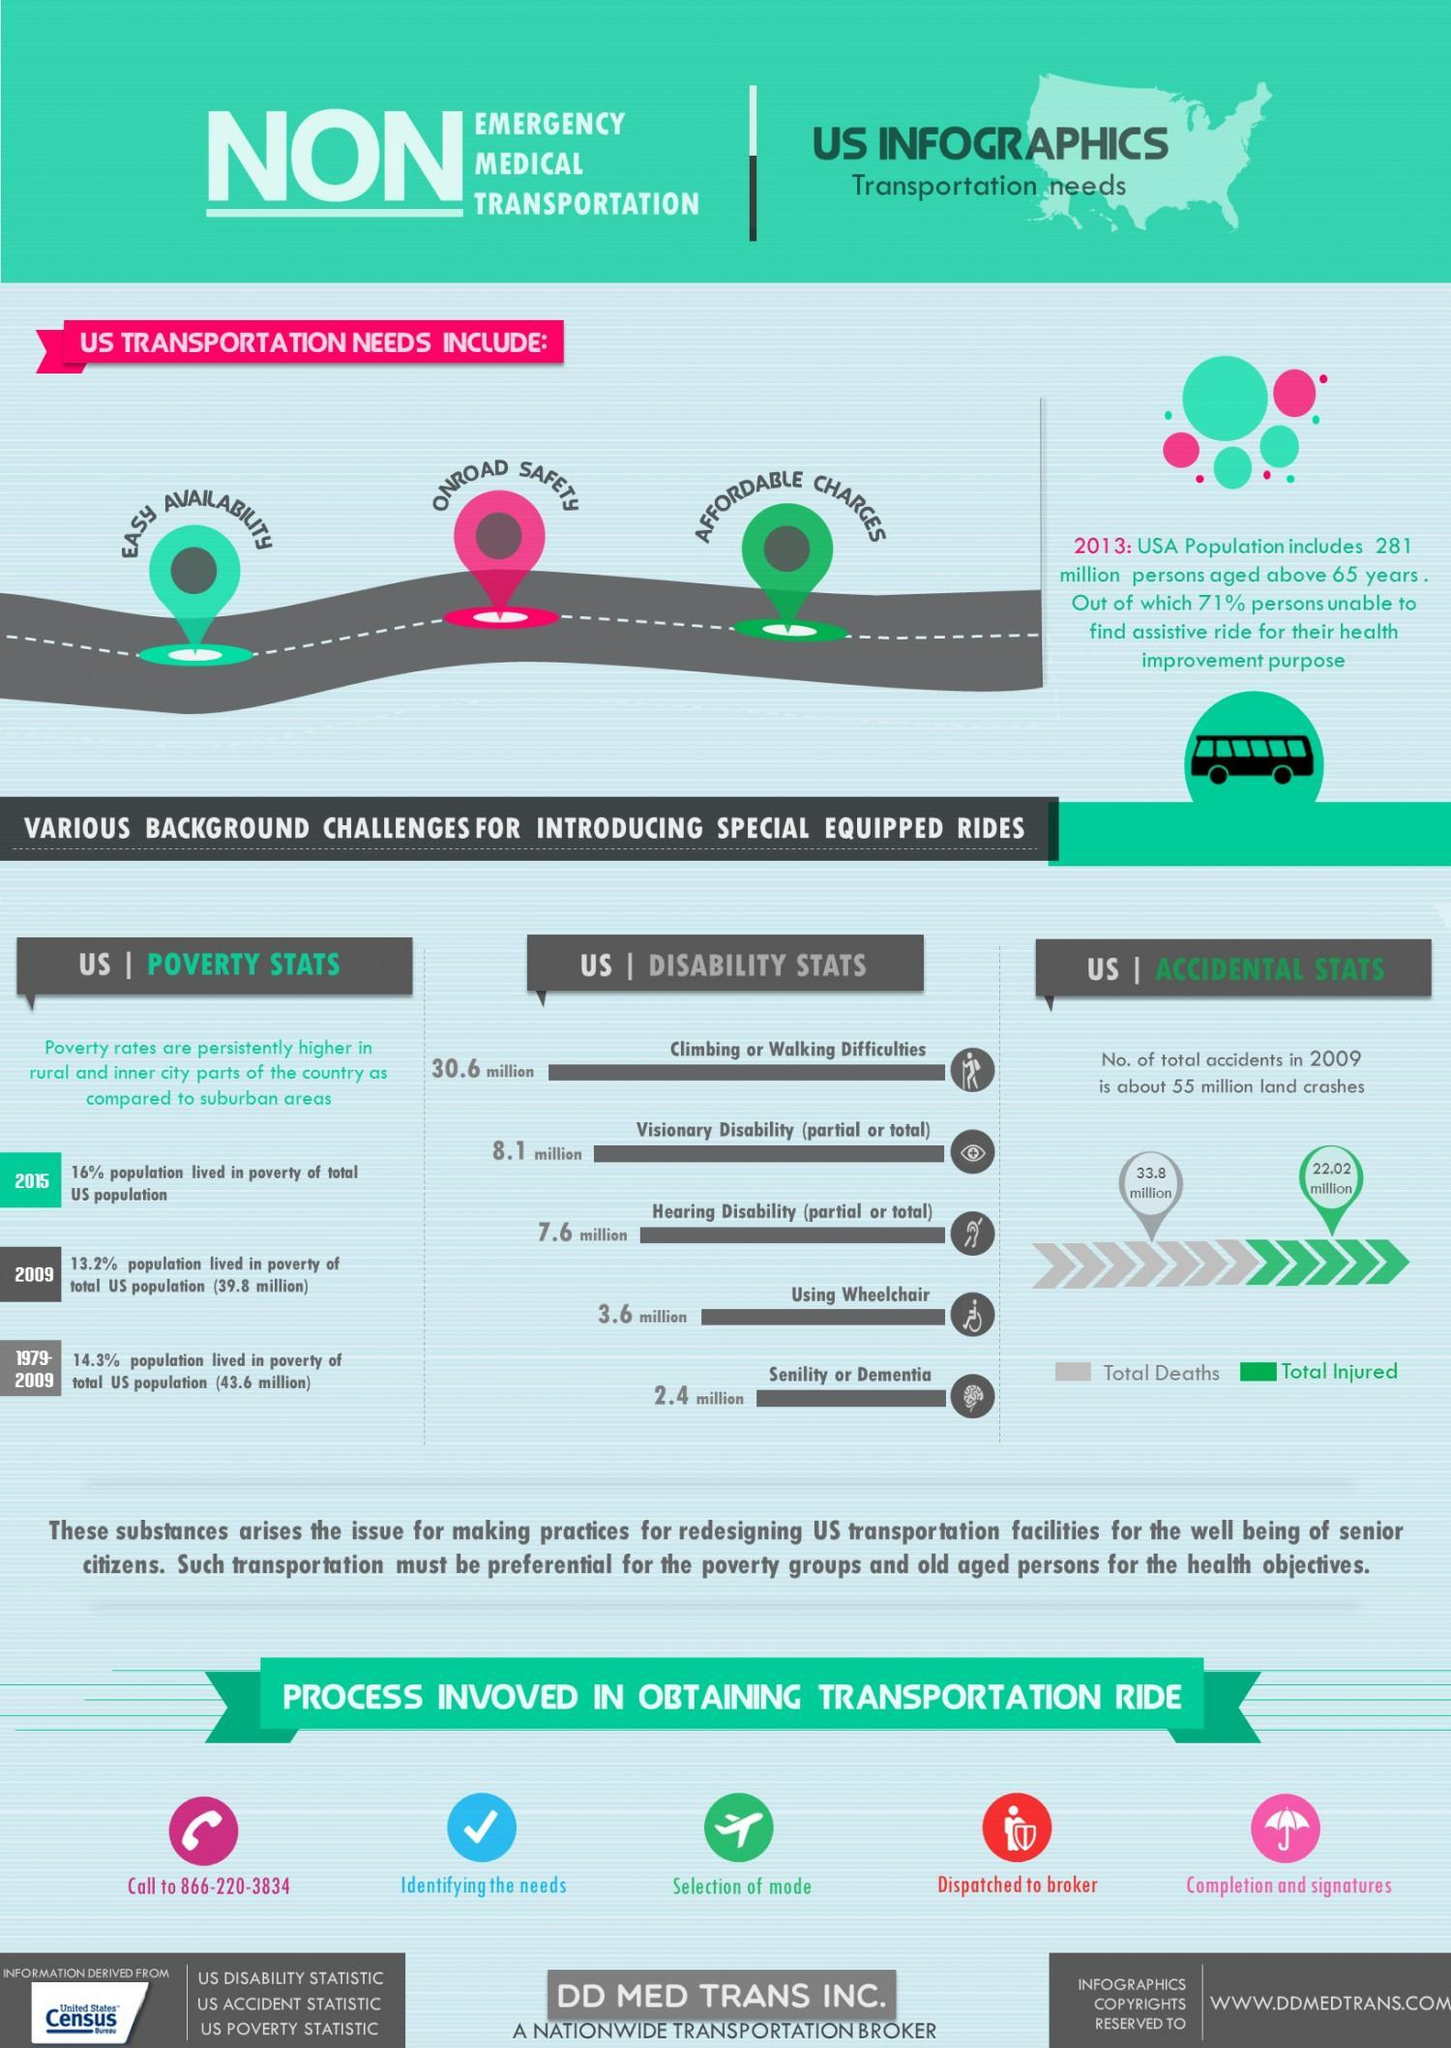what process does the aeroplane show
Answer the question with a short phrase. selection of mode which year has there been a reduction in poverty rate 2009 what is the difference between total deaths and total injured 11.78 what colour is affordable charges shown in, red or green green what is the sum of people in million with visionary disability and senility 10.5 what process does the umbrella show completion and signatures 